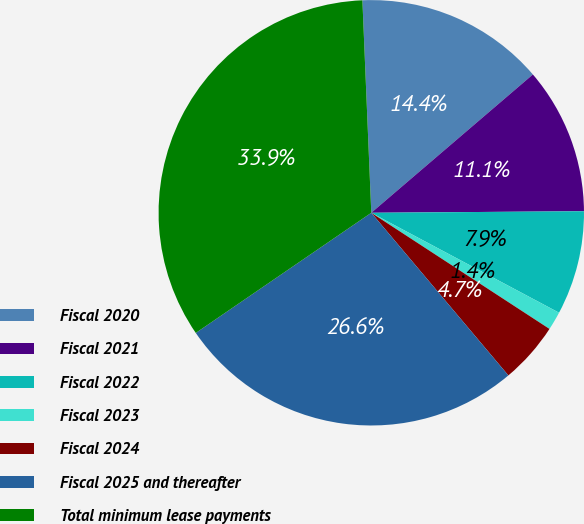<chart> <loc_0><loc_0><loc_500><loc_500><pie_chart><fcel>Fiscal 2020<fcel>Fiscal 2021<fcel>Fiscal 2022<fcel>Fiscal 2023<fcel>Fiscal 2024<fcel>Fiscal 2025 and thereafter<fcel>Total minimum lease payments<nl><fcel>14.4%<fcel>11.15%<fcel>7.9%<fcel>1.41%<fcel>4.66%<fcel>26.59%<fcel>33.89%<nl></chart> 